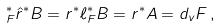<formula> <loc_0><loc_0><loc_500><loc_500>\L _ { F } ^ { \ast } \hat { r } ^ { \ast } B = r ^ { \ast } \ell _ { F } ^ { \ast } B = r ^ { \ast } A = d _ { v } F \, ,</formula> 